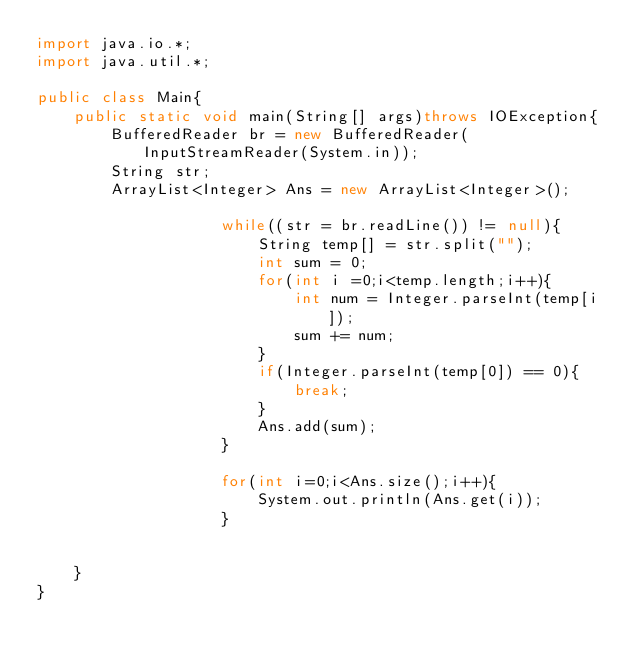<code> <loc_0><loc_0><loc_500><loc_500><_Java_>import java.io.*;
import java.util.*;

public class Main{
    public static void main(String[] args)throws IOException{
        BufferedReader br = new BufferedReader(InputStreamReader(System.in));
        String str;
        ArrayList<Integer> Ans = new ArrayList<Integer>();

                    while((str = br.readLine()) != null){
                        String temp[] = str.split("");
                        int sum = 0;
                        for(int i =0;i<temp.length;i++){
                            int num = Integer.parseInt(temp[i]);
                            sum += num;
                        }
                        if(Integer.parseInt(temp[0]) == 0){
                            break;
                        } 
                        Ans.add(sum);
                    }

                    for(int i=0;i<Ans.size();i++){
                        System.out.println(Ans.get(i));
                    }


    }
}</code> 